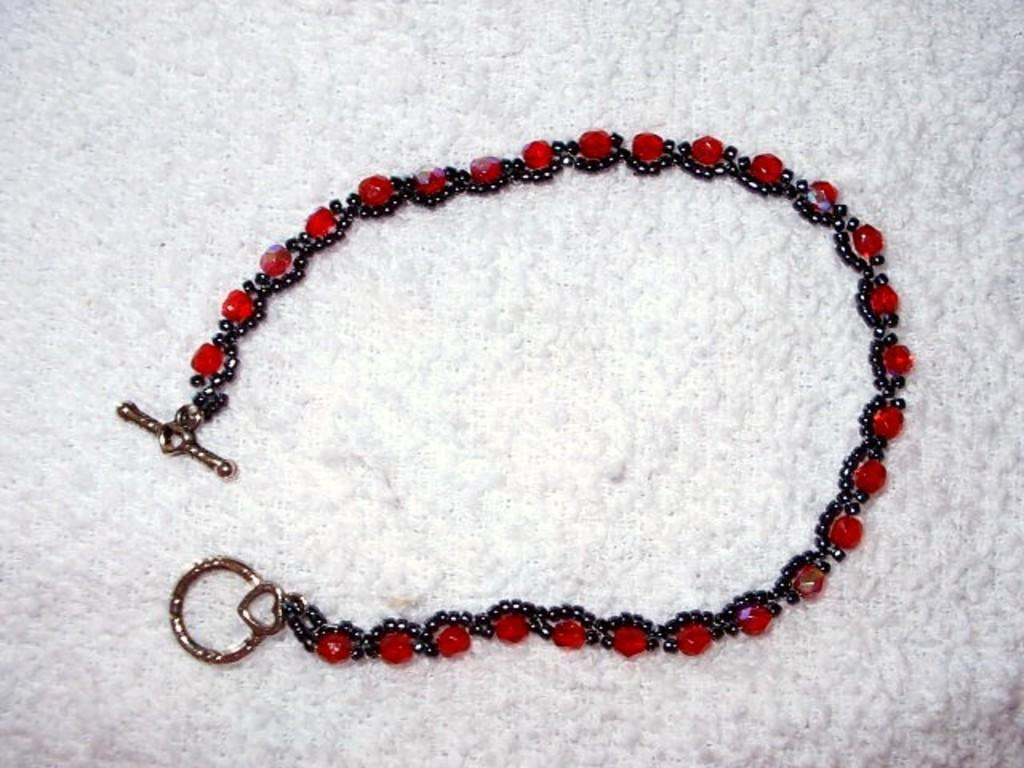What is the main subject of the image? The main subject of the image is an ornament. What colors are used in the ornament? The ornament is made up of red and black color gems. What is the color of the surface on which the ornament is placed? The ornament is placed on a white surface. What type of music can be heard coming from the ornament in the image? There is no music coming from the or associated with the ornament in the image. 